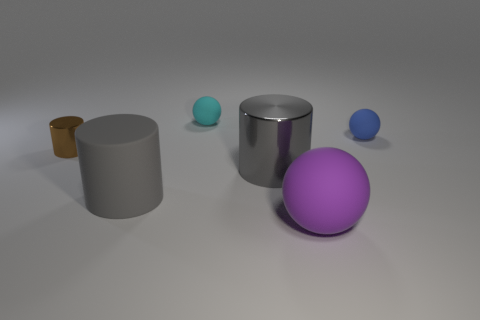Is the size of the brown metal thing the same as the matte ball that is in front of the small metallic object?
Keep it short and to the point. No. What number of cylinders are big gray metal things or tiny brown metal things?
Make the answer very short. 2. What number of things are on the left side of the large gray rubber cylinder and on the right side of the tiny metal cylinder?
Your answer should be compact. 0. How many other objects are the same color as the tiny cylinder?
Your answer should be compact. 0. There is a gray object that is on the right side of the gray matte object; what shape is it?
Keep it short and to the point. Cylinder. Does the purple ball have the same material as the tiny cyan ball?
Offer a terse response. Yes. Is there anything else that has the same size as the cyan sphere?
Provide a succinct answer. Yes. There is a small blue rubber object; how many small matte balls are behind it?
Your answer should be compact. 1. The shiny object left of the shiny object to the right of the gray rubber cylinder is what shape?
Keep it short and to the point. Cylinder. Is there any other thing that is the same shape as the small cyan rubber object?
Offer a very short reply. Yes. 